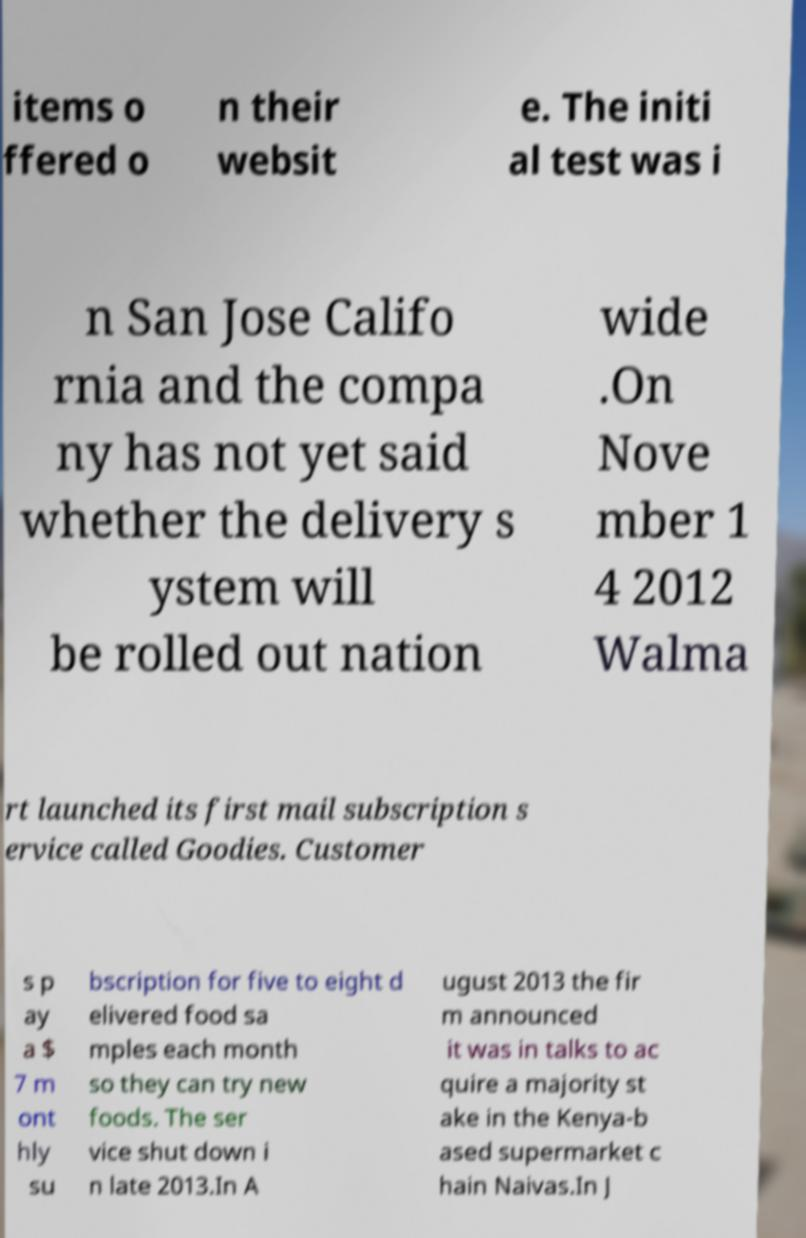I need the written content from this picture converted into text. Can you do that? items o ffered o n their websit e. The initi al test was i n San Jose Califo rnia and the compa ny has not yet said whether the delivery s ystem will be rolled out nation wide .On Nove mber 1 4 2012 Walma rt launched its first mail subscription s ervice called Goodies. Customer s p ay a $ 7 m ont hly su bscription for five to eight d elivered food sa mples each month so they can try new foods. The ser vice shut down i n late 2013.In A ugust 2013 the fir m announced it was in talks to ac quire a majority st ake in the Kenya-b ased supermarket c hain Naivas.In J 